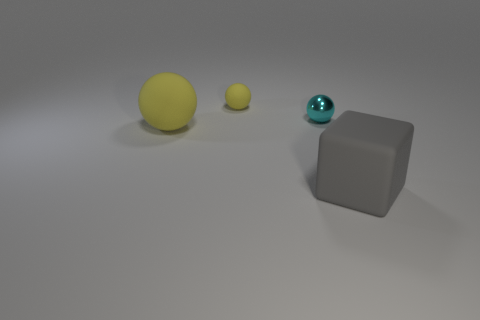If these objects were part of a story, what role could they play? In a narrative context, these objects could symbolize characters or elements of a plot. Imagine the larger yellow sphere as a radiant sun, the smaller cyan sphere as a distant planet, and the matte gray cube as a mysterious monolith with untold powers or secrets. The arrangement could depict a scene of cosmic balance, with each object playing a unique role in a greater celestial story. 